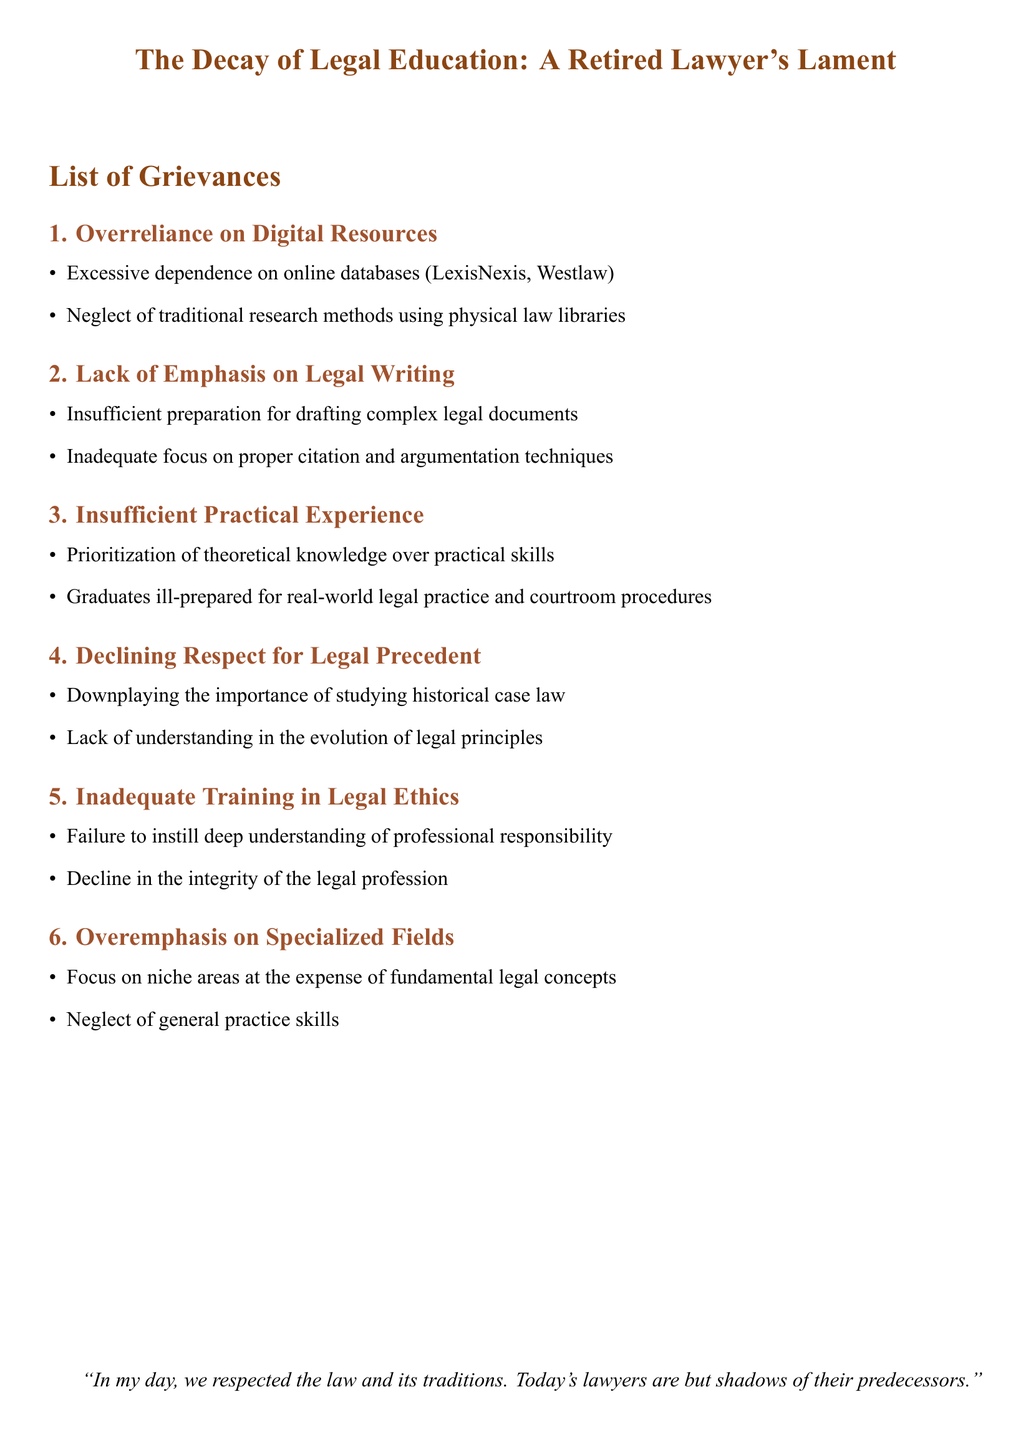What is the title of the document? The title is specifically mentioned at the beginning of the document.
Answer: The Decay of Legal Education: A Retired Lawyer's Lament How many grievances are listed in the document? The number of grievances is explicitly noted within the list of grievances section.
Answer: 6 What is the first grievance mentioned? The title of the first grievance is clearly stated in the document.
Answer: Overreliance on Digital Resources What does the third grievance emphasize? The details of the third grievance provide insights about the focus of modern legal education.
Answer: Insufficient Practical Experience Which grievance discusses legal ethics? The grievance discussing legal ethics is labeled distinctly in the document.
Answer: Inadequate Training in Legal Ethics What traditional method is being neglected according to the grievances? The document specifically identifies the traditional method that has been overlooked.
Answer: Physical law libraries and print resources What issue relates to specialized fields in legal education? The document highlights a specific concern regarding niche areas in legal education.
Answer: Overemphasis on Specialized Fields 